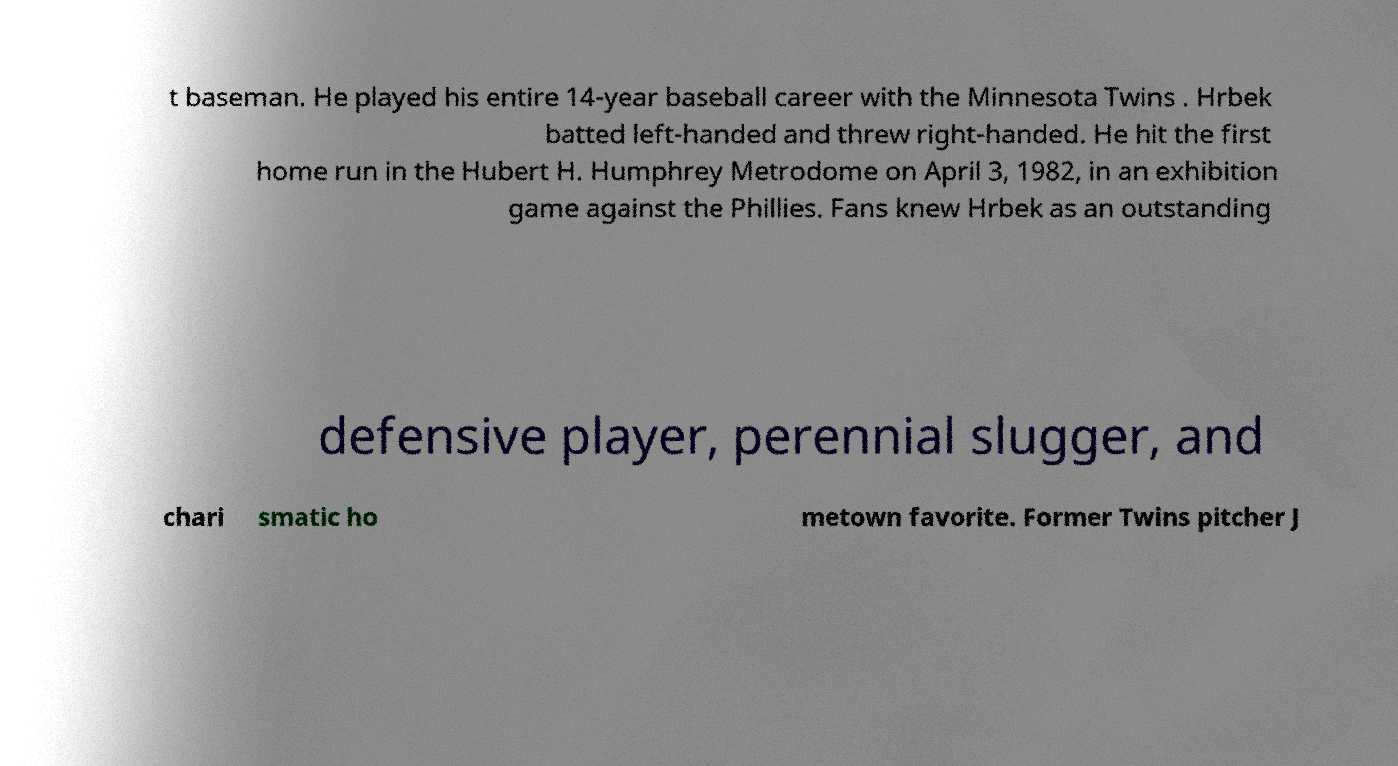Please identify and transcribe the text found in this image. t baseman. He played his entire 14-year baseball career with the Minnesota Twins . Hrbek batted left-handed and threw right-handed. He hit the first home run in the Hubert H. Humphrey Metrodome on April 3, 1982, in an exhibition game against the Phillies. Fans knew Hrbek as an outstanding defensive player, perennial slugger, and chari smatic ho metown favorite. Former Twins pitcher J 